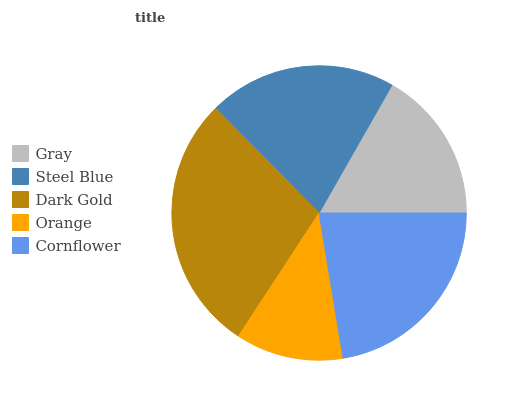Is Orange the minimum?
Answer yes or no. Yes. Is Dark Gold the maximum?
Answer yes or no. Yes. Is Steel Blue the minimum?
Answer yes or no. No. Is Steel Blue the maximum?
Answer yes or no. No. Is Steel Blue greater than Gray?
Answer yes or no. Yes. Is Gray less than Steel Blue?
Answer yes or no. Yes. Is Gray greater than Steel Blue?
Answer yes or no. No. Is Steel Blue less than Gray?
Answer yes or no. No. Is Steel Blue the high median?
Answer yes or no. Yes. Is Steel Blue the low median?
Answer yes or no. Yes. Is Gray the high median?
Answer yes or no. No. Is Dark Gold the low median?
Answer yes or no. No. 